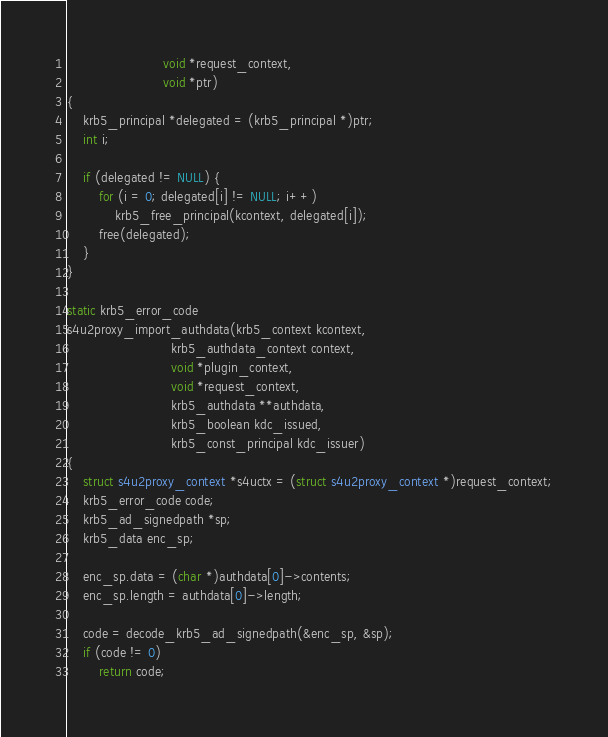<code> <loc_0><loc_0><loc_500><loc_500><_C_>                        void *request_context,
                        void *ptr)
{
    krb5_principal *delegated = (krb5_principal *)ptr;
    int i;

    if (delegated != NULL) {
        for (i = 0; delegated[i] != NULL; i++)
            krb5_free_principal(kcontext, delegated[i]);
        free(delegated);
    }
}

static krb5_error_code
s4u2proxy_import_authdata(krb5_context kcontext,
                          krb5_authdata_context context,
                          void *plugin_context,
                          void *request_context,
                          krb5_authdata **authdata,
                          krb5_boolean kdc_issued,
                          krb5_const_principal kdc_issuer)
{
    struct s4u2proxy_context *s4uctx = (struct s4u2proxy_context *)request_context;
    krb5_error_code code;
    krb5_ad_signedpath *sp;
    krb5_data enc_sp;

    enc_sp.data = (char *)authdata[0]->contents;
    enc_sp.length = authdata[0]->length;

    code = decode_krb5_ad_signedpath(&enc_sp, &sp);
    if (code != 0)
        return code;
</code> 